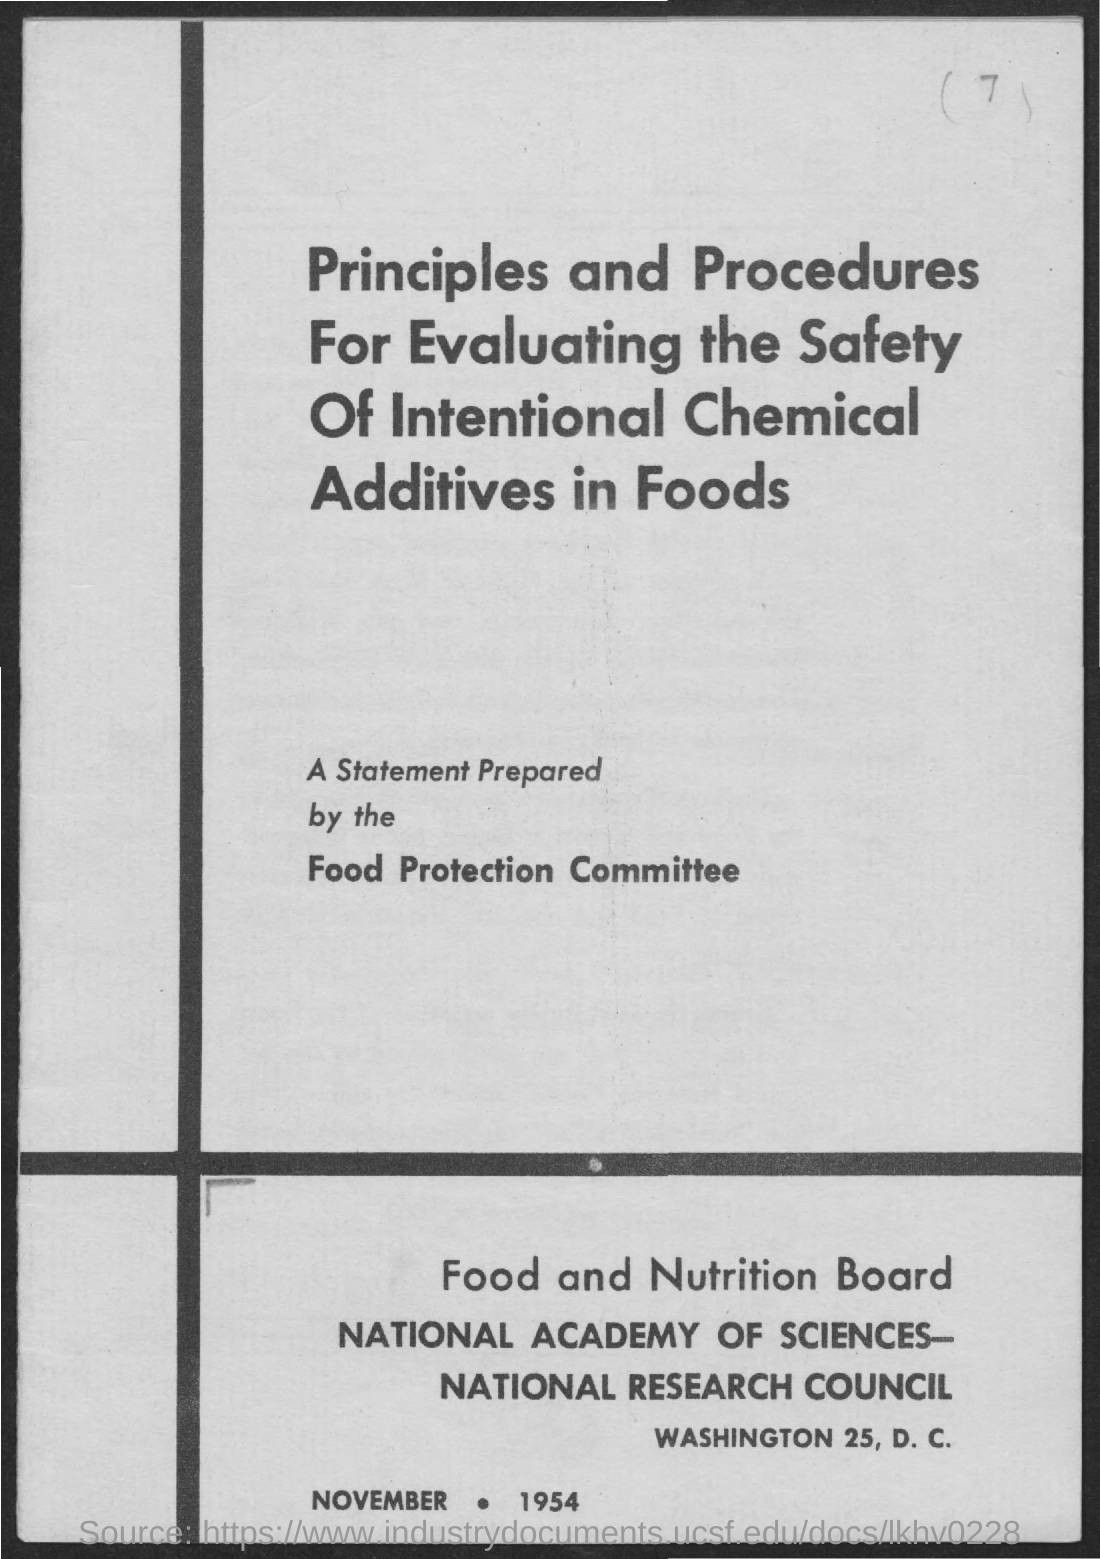What is the date mentioned in this document?
Provide a short and direct response. November 1954. 